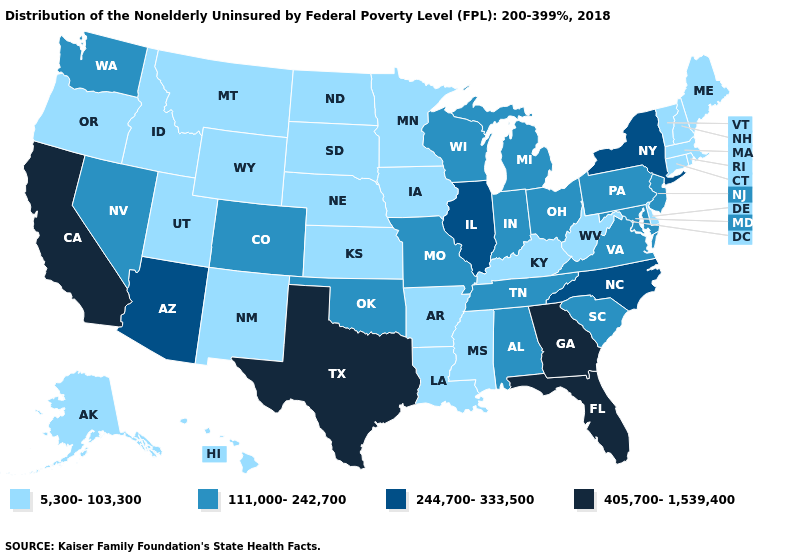What is the value of Kansas?
Short answer required. 5,300-103,300. Name the states that have a value in the range 5,300-103,300?
Write a very short answer. Alaska, Arkansas, Connecticut, Delaware, Hawaii, Idaho, Iowa, Kansas, Kentucky, Louisiana, Maine, Massachusetts, Minnesota, Mississippi, Montana, Nebraska, New Hampshire, New Mexico, North Dakota, Oregon, Rhode Island, South Dakota, Utah, Vermont, West Virginia, Wyoming. Name the states that have a value in the range 111,000-242,700?
Be succinct. Alabama, Colorado, Indiana, Maryland, Michigan, Missouri, Nevada, New Jersey, Ohio, Oklahoma, Pennsylvania, South Carolina, Tennessee, Virginia, Washington, Wisconsin. What is the value of Georgia?
Keep it brief. 405,700-1,539,400. Name the states that have a value in the range 405,700-1,539,400?
Short answer required. California, Florida, Georgia, Texas. Does Idaho have a higher value than Vermont?
Write a very short answer. No. What is the highest value in states that border Indiana?
Quick response, please. 244,700-333,500. Does Massachusetts have the highest value in the USA?
Concise answer only. No. What is the value of Connecticut?
Quick response, please. 5,300-103,300. Name the states that have a value in the range 244,700-333,500?
Answer briefly. Arizona, Illinois, New York, North Carolina. What is the value of Mississippi?
Be succinct. 5,300-103,300. Does Maryland have the highest value in the USA?
Answer briefly. No. Name the states that have a value in the range 5,300-103,300?
Answer briefly. Alaska, Arkansas, Connecticut, Delaware, Hawaii, Idaho, Iowa, Kansas, Kentucky, Louisiana, Maine, Massachusetts, Minnesota, Mississippi, Montana, Nebraska, New Hampshire, New Mexico, North Dakota, Oregon, Rhode Island, South Dakota, Utah, Vermont, West Virginia, Wyoming. Name the states that have a value in the range 244,700-333,500?
Keep it brief. Arizona, Illinois, New York, North Carolina. What is the value of Oregon?
Answer briefly. 5,300-103,300. 